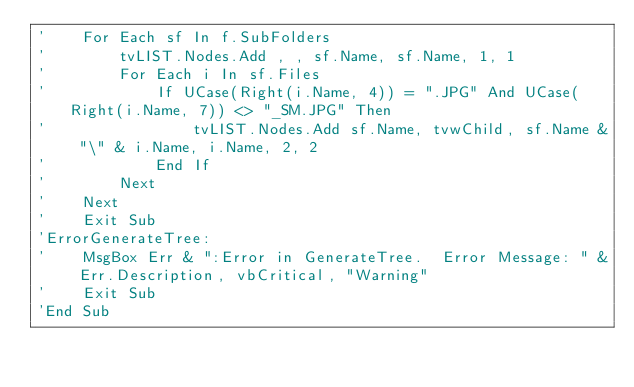<code> <loc_0><loc_0><loc_500><loc_500><_VisualBasic_>'    For Each sf In f.SubFolders
'        tvLIST.Nodes.Add , , sf.Name, sf.Name, 1, 1
'        For Each i In sf.Files
'            If UCase(Right(i.Name, 4)) = ".JPG" And UCase(Right(i.Name, 7)) <> "_SM.JPG" Then
'                tvLIST.Nodes.Add sf.Name, tvwChild, sf.Name & "\" & i.Name, i.Name, 2, 2
'            End If
'        Next
'    Next
'    Exit Sub
'ErrorGenerateTree:
'    MsgBox Err & ":Error in GenerateTree.  Error Message: " & Err.Description, vbCritical, "Warning"
'    Exit Sub
'End Sub
</code> 